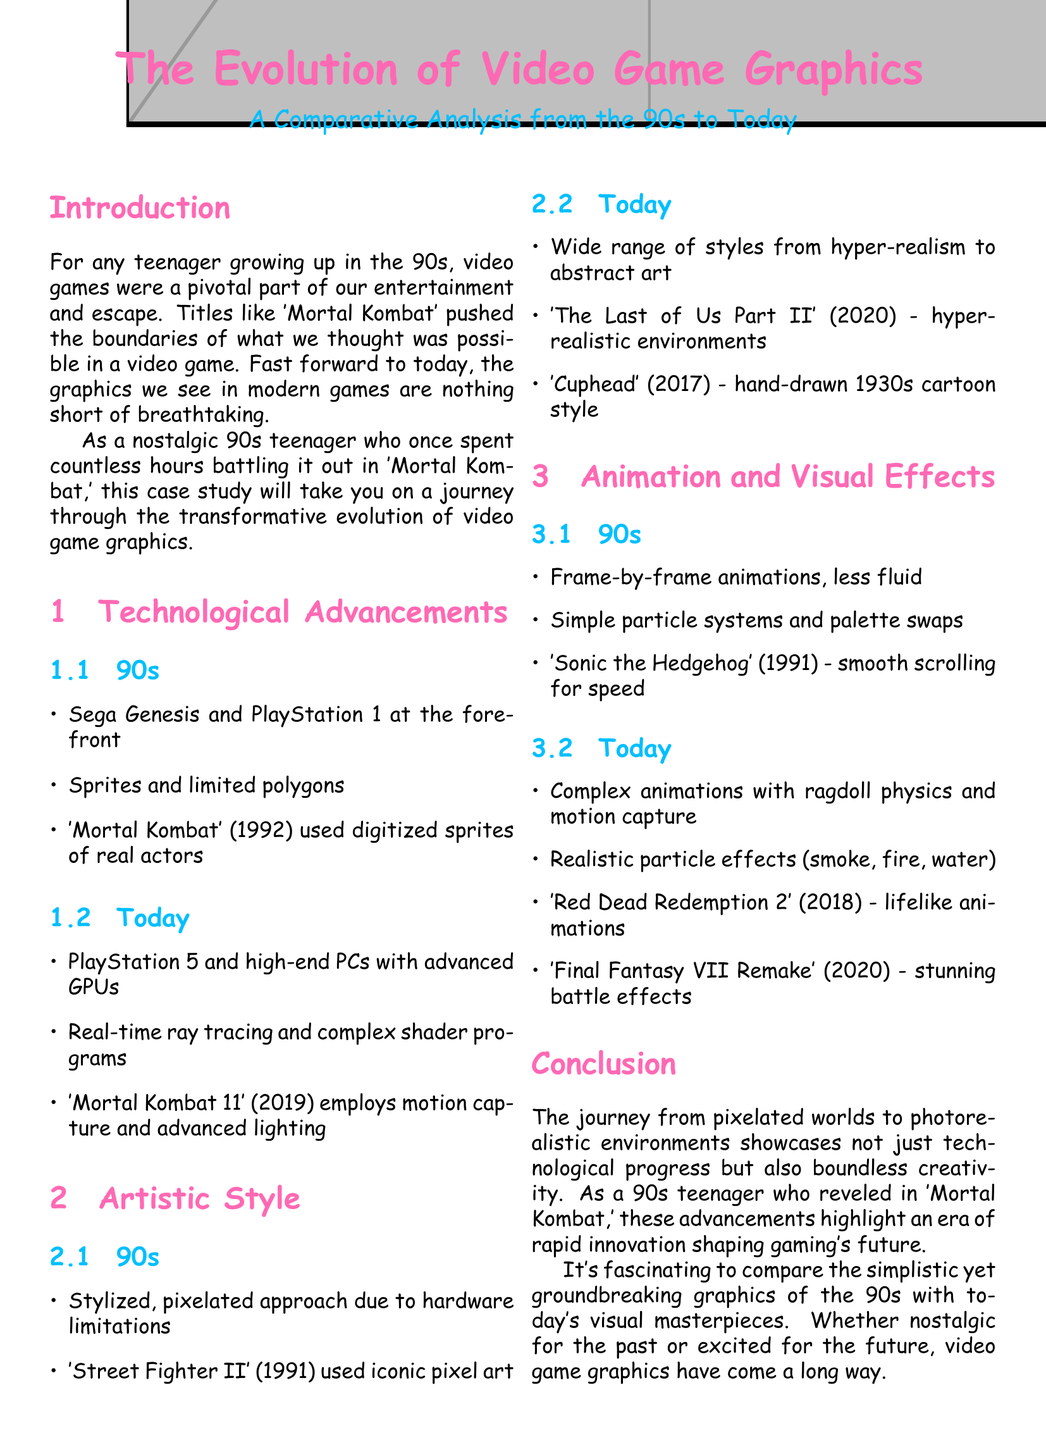What video game was mentioned from the 90s that used digitized sprites? 'Mortal Kombat' (1992) is highlighted in the document for its use of digitized sprites of real actors during the 90s.
Answer: 'Mortal Kombat' What technology is specifically associated with modern gaming graphics? The case study mentions advanced GPUs and real-time ray tracing as key technologies for today's graphics.
Answer: Advanced GPUs Which game from 2020 is mentioned for its hyper-realistic environments? The document references 'The Last of Us Part II' (2020) as an example of a game with hyper-realistic environments.
Answer: 'The Last of Us Part II' What animation technique was commonly used in the 90s? Frame-by-frame animations are described as a common technique during the 90s for games.
Answer: Frame-by-frame animations Which game is noted for its stunning battle effects from 2020? 'Final Fantasy VII Remake' (2020) is specifically mentioned for its stunning battle effects.
Answer: 'Final Fantasy VII Remake' What artistic approach was typical of 90s video games? A stylized, pixelated approach was typical due to hardware limitations during the 90s, as discussed in the document.
Answer: Stylized, pixelated approach Name one modern game that uses motion capture technology. 'Mortal Kombat 11' (2019) is cited as employing motion capture for its character animations.
Answer: 'Mortal Kombat 11' How did the visual effects change from the 90s to today? The document mentions that today's visuals feature complex animations with ragdoll physics compared to the simpler effects of the 90s.
Answer: Complex animations with ragdoll physics 